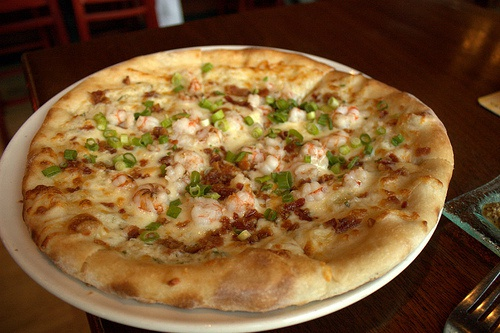Describe the objects in this image and their specific colors. I can see pizza in maroon, olive, and tan tones, dining table in maroon, black, and gray tones, chair in maroon and black tones, fork in maroon, black, and gray tones, and chair in maroon, black, and brown tones in this image. 